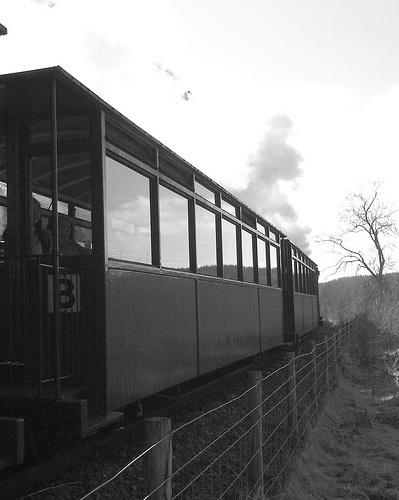Is this train likely to be a commuter or tourist train? This train likely serves as a tourist train, given its historical design and the scenic route it appears to be traveling on, which is typical for trains aimed at sightseeing. 